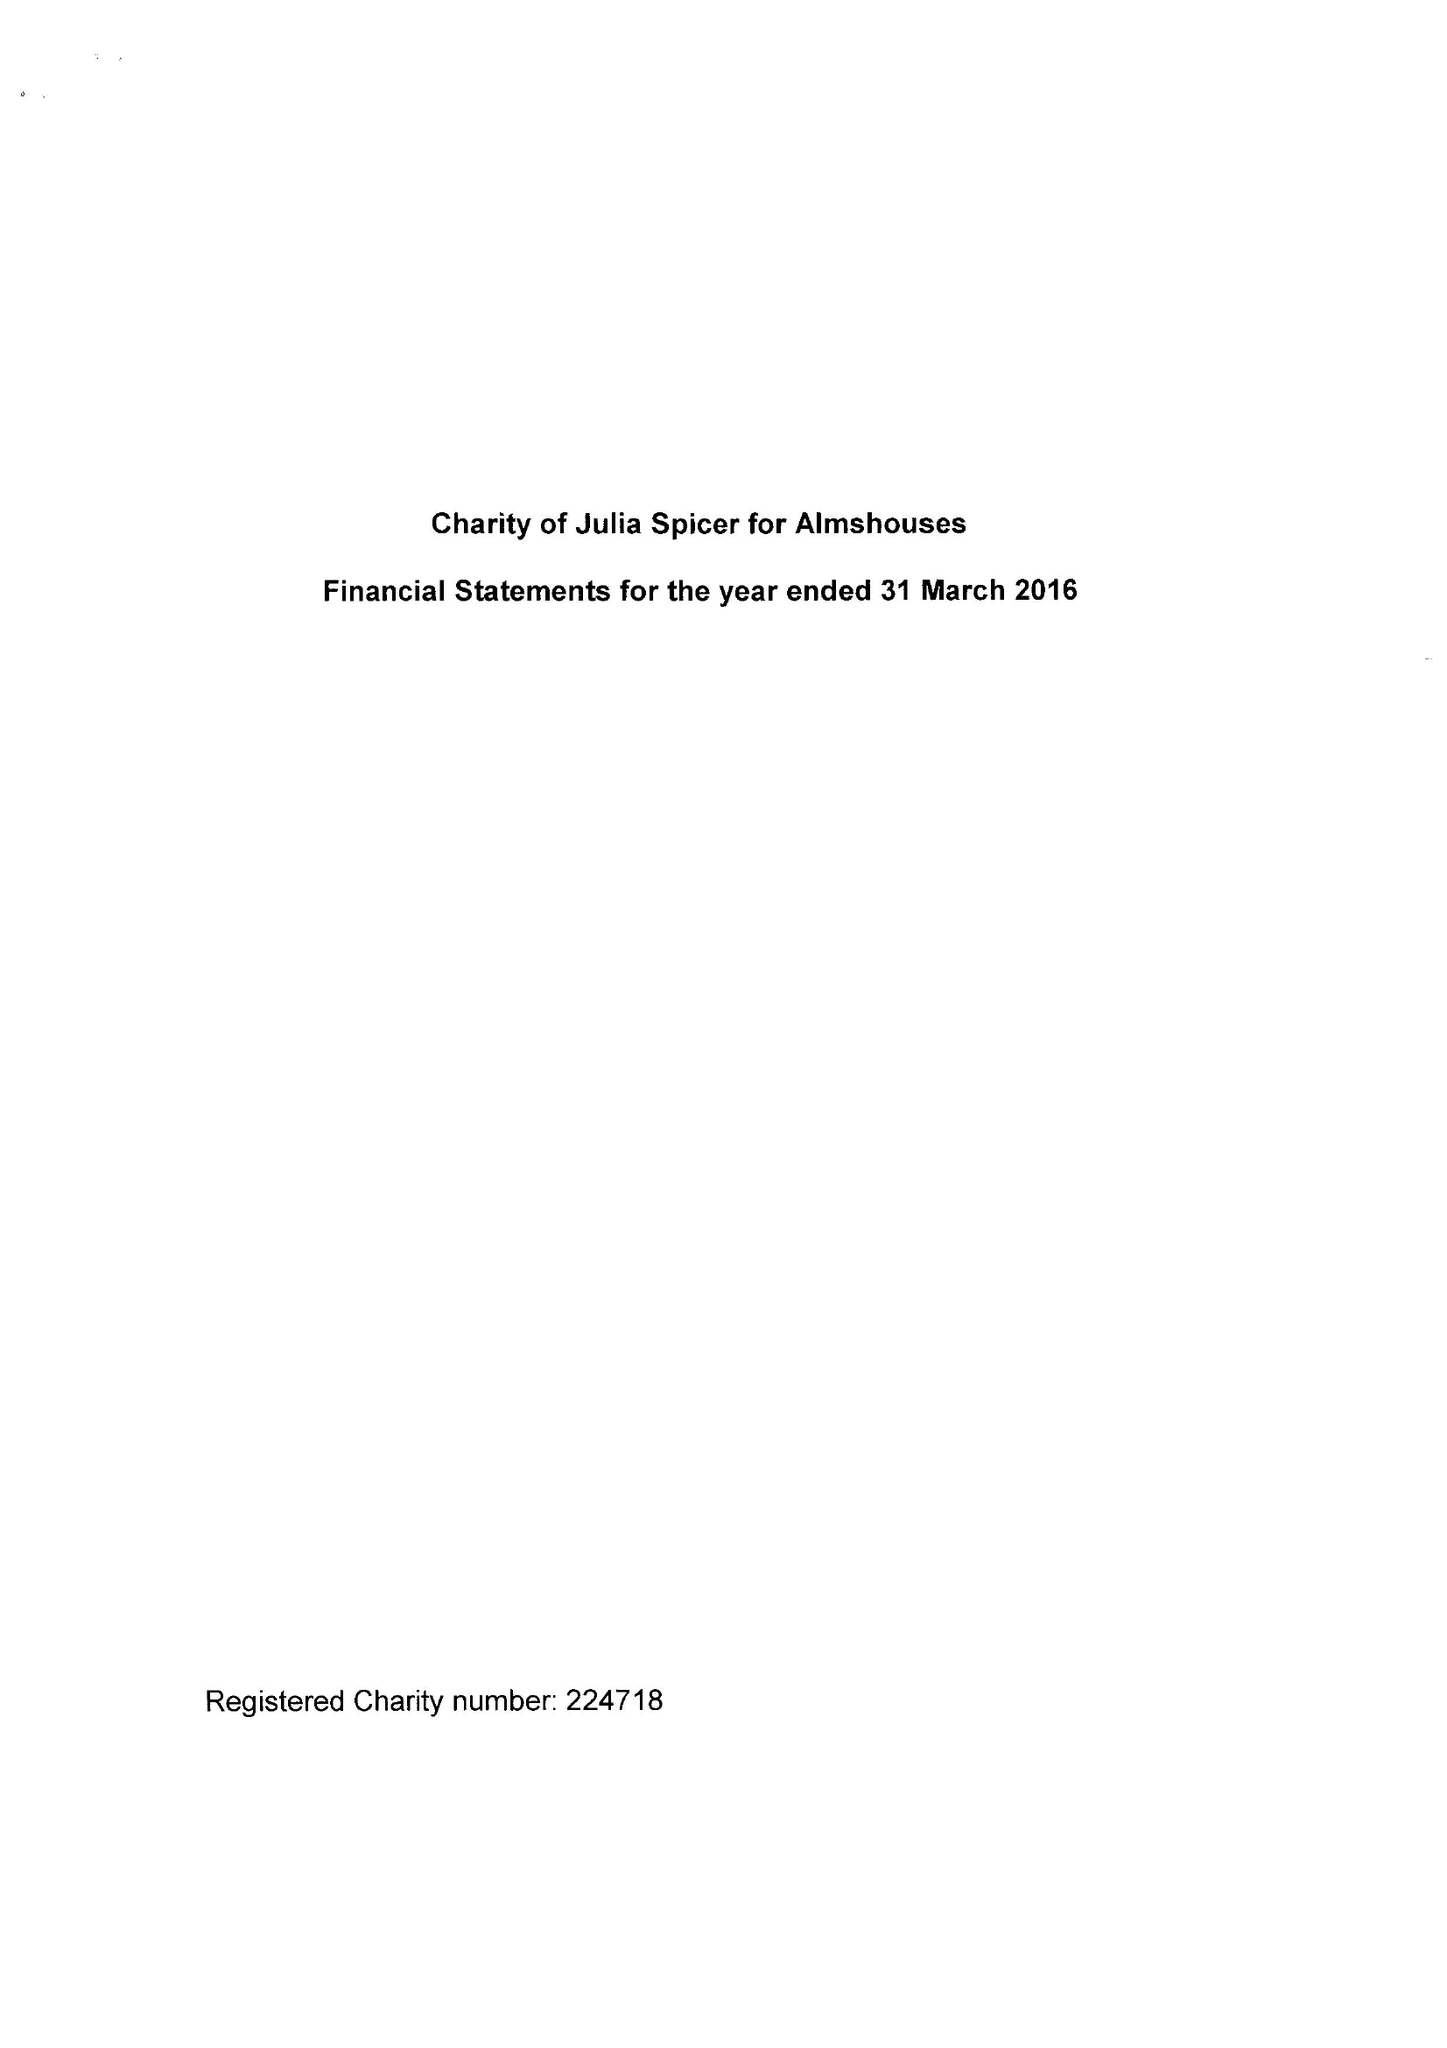What is the value for the charity_number?
Answer the question using a single word or phrase. 224718 